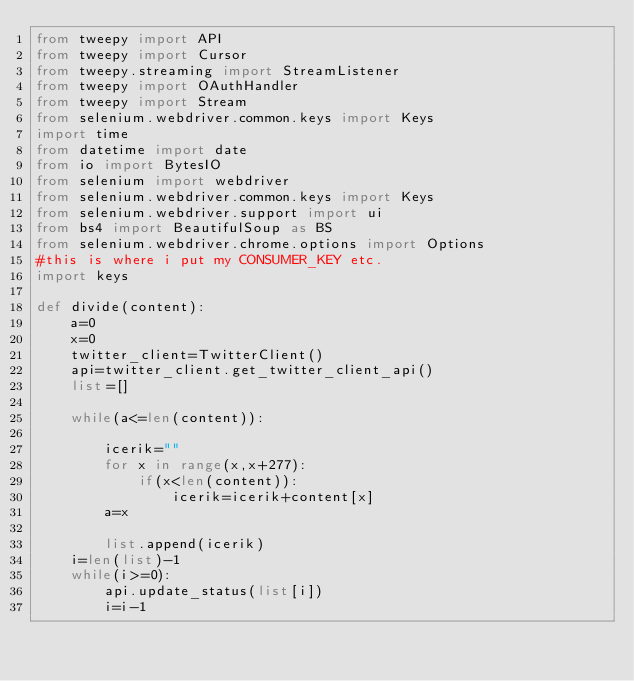<code> <loc_0><loc_0><loc_500><loc_500><_Python_>from tweepy import API
from tweepy import Cursor
from tweepy.streaming import StreamListener
from tweepy import OAuthHandler
from tweepy import Stream
from selenium.webdriver.common.keys import Keys
import time
from datetime import date
from io import BytesIO
from selenium import webdriver
from selenium.webdriver.common.keys import Keys
from selenium.webdriver.support import ui
from bs4 import BeautifulSoup as BS
from selenium.webdriver.chrome.options import Options
#this is where i put my CONSUMER_KEY etc.
import keys

def divide(content):
    a=0
    x=0
    twitter_client=TwitterClient()
    api=twitter_client.get_twitter_client_api()
    list=[]
    
    while(a<=len(content)):
        
        icerik=""
        for x in range(x,x+277):
            if(x<len(content)):
                icerik=icerik+content[x]
        a=x
        
        list.append(icerik)
    i=len(list)-1
    while(i>=0):
        api.update_status(list[i])
        i=i-1


                
      
</code> 